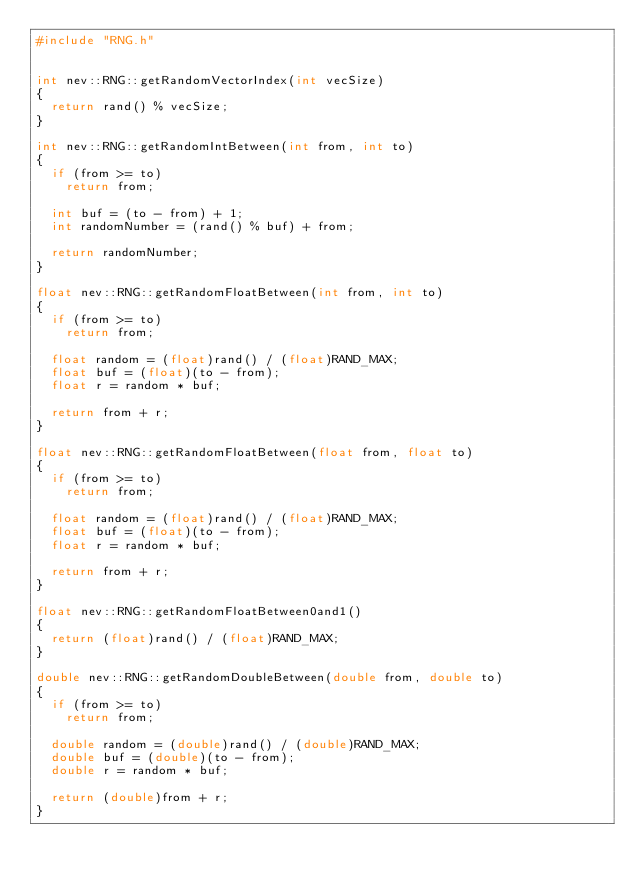Convert code to text. <code><loc_0><loc_0><loc_500><loc_500><_C++_>#include "RNG.h"


int nev::RNG::getRandomVectorIndex(int vecSize)
{
	return rand() % vecSize;
}

int nev::RNG::getRandomIntBetween(int from, int to)
{
	if (from >= to)
		return from;

	int buf = (to - from) + 1;
	int randomNumber = (rand() % buf) + from;

	return randomNumber;
}

float nev::RNG::getRandomFloatBetween(int from, int to)
{
	if (from >= to)
		return from;

	float random = (float)rand() / (float)RAND_MAX;
	float buf = (float)(to - from);
	float r = random * buf;

	return from + r;
}

float nev::RNG::getRandomFloatBetween(float from, float to)
{
	if (from >= to)
		return from;

	float random = (float)rand() / (float)RAND_MAX;
	float buf = (float)(to - from);
	float r = random * buf;

	return from + r;
}

float nev::RNG::getRandomFloatBetween0and1()
{
	return (float)rand() / (float)RAND_MAX;
}

double nev::RNG::getRandomDoubleBetween(double from, double to)
{
	if (from >= to)
		return from;

	double random = (double)rand() / (double)RAND_MAX;
	double buf = (double)(to - from);
	double r = random * buf;

	return (double)from + r;
}
</code> 